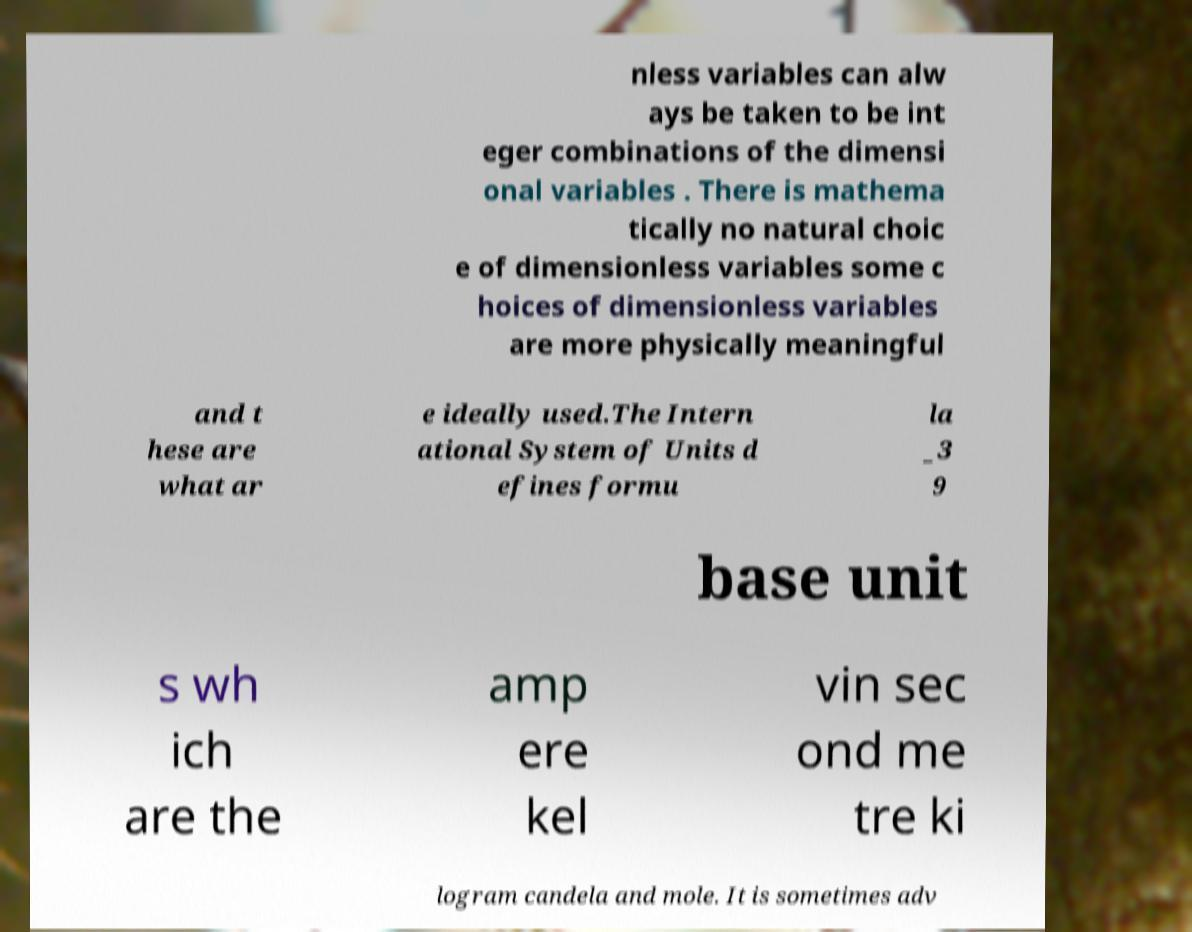Please identify and transcribe the text found in this image. nless variables can alw ays be taken to be int eger combinations of the dimensi onal variables . There is mathema tically no natural choic e of dimensionless variables some c hoices of dimensionless variables are more physically meaningful and t hese are what ar e ideally used.The Intern ational System of Units d efines formu la _3 9 base unit s wh ich are the amp ere kel vin sec ond me tre ki logram candela and mole. It is sometimes adv 